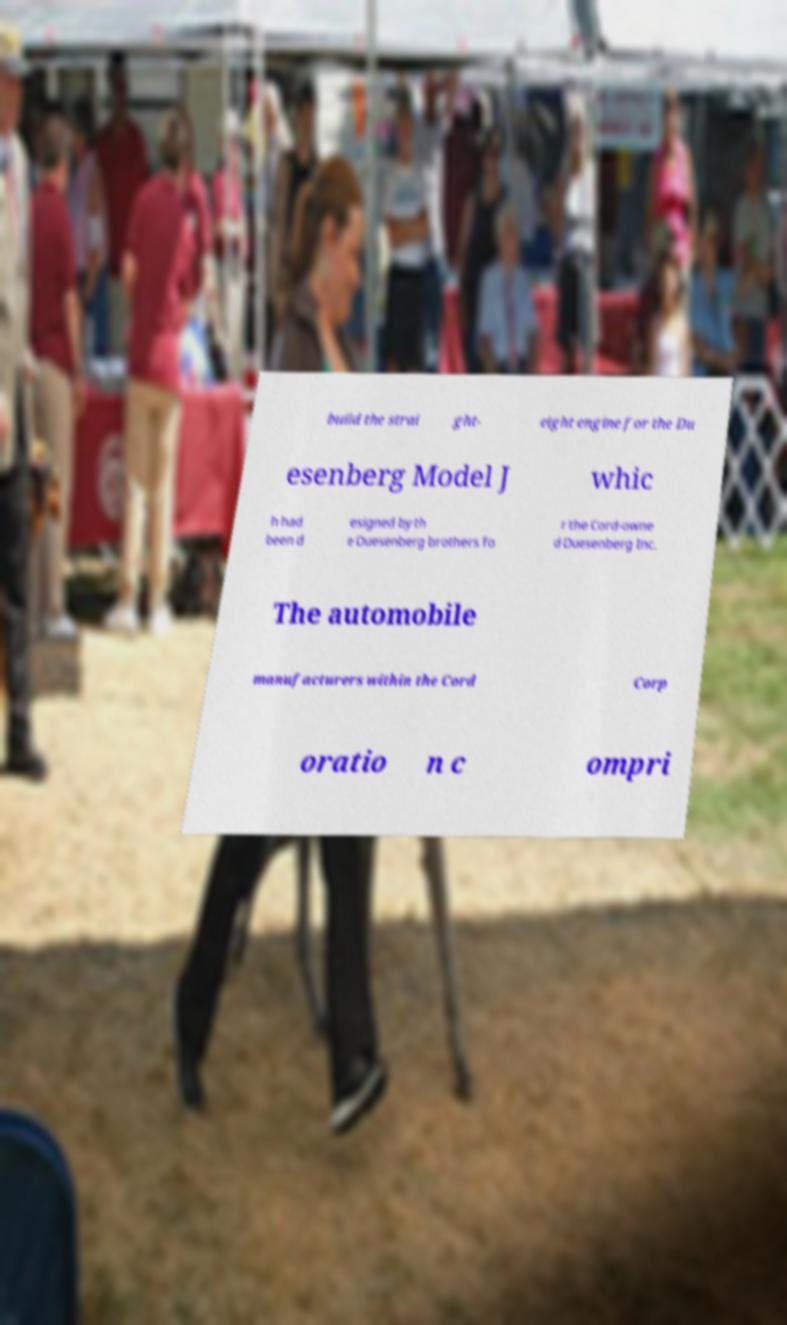Please identify and transcribe the text found in this image. build the strai ght- eight engine for the Du esenberg Model J whic h had been d esigned by th e Duesenberg brothers fo r the Cord-owne d Duesenberg Inc. The automobile manufacturers within the Cord Corp oratio n c ompri 